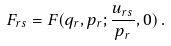<formula> <loc_0><loc_0><loc_500><loc_500>F _ { r s } = F ( q _ { r } , p _ { r } ; \frac { u _ { r s } } { p _ { r } } , 0 ) \, .</formula> 